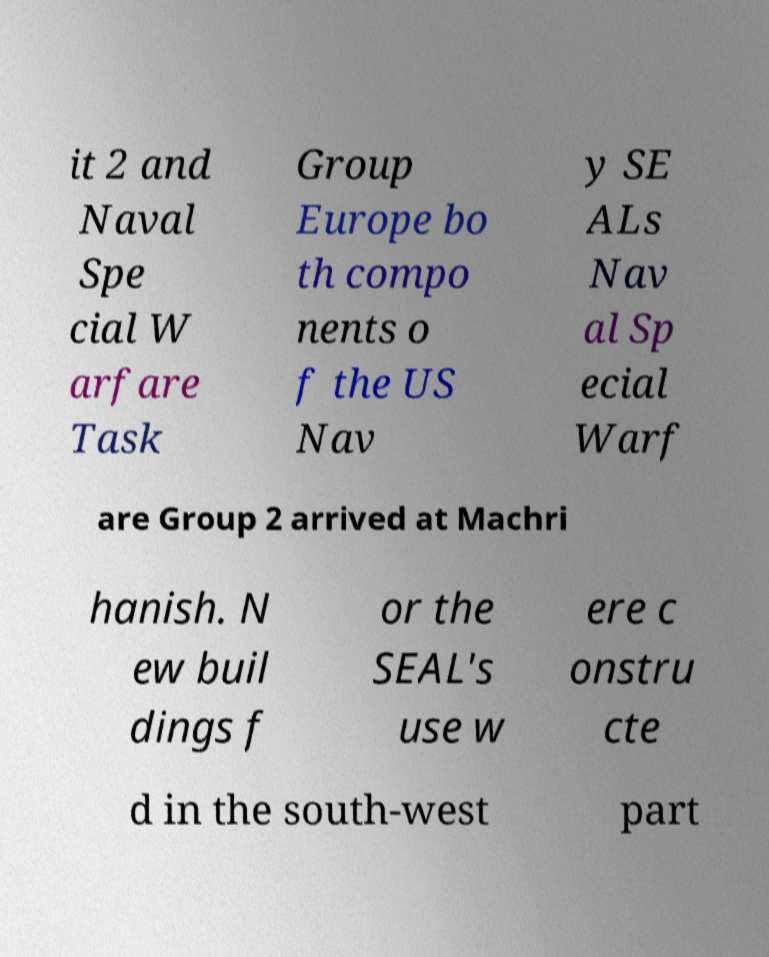For documentation purposes, I need the text within this image transcribed. Could you provide that? it 2 and Naval Spe cial W arfare Task Group Europe bo th compo nents o f the US Nav y SE ALs Nav al Sp ecial Warf are Group 2 arrived at Machri hanish. N ew buil dings f or the SEAL's use w ere c onstru cte d in the south-west part 